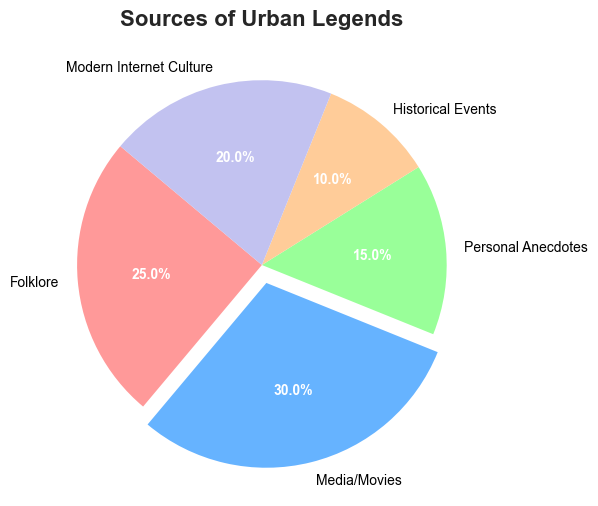What is the largest source of urban legends? The figure shows a pie chart with different sources of urban legends. The segment labeled 'Media/Movies' has the highest percentage at 30%.
Answer: Media/Movies What is the smallest source of urban legends? By examining the pie chart, the segment labeled 'Historical Events' has the smallest percentage at 10%.
Answer: Historical Events Which source is represented by the red slice? The pie chart uses different colors for the segments, and the legend/helper labels guide us. The 'Folklore' category is represented by the red slice.
Answer: Folklore What is the combined percentage of urban legends from Personal Anecdotes and Modern Internet Culture? The percentages for Personal Anecdotes and Modern Internet Culture are 15% and 20%, respectively. Adding them gives 15 + 20 = 35%.
Answer: 35% How much larger is the Media/Movies segment compared to the Historical Events segment? The percentage for Media/Movies is 30%, and for Historical Events, it is 10%. The difference is 30 - 10 = 20%.
Answer: 20% What percentage of urban legends come from sources other than Media/Movies? The total percentage is 100%. The Media/Movies segment is 30%. So, the percentage from other sources is 100 - 30 = 70%.
Answer: 70% Which two sources have the closest percentages? By examining the pie chart, Folklore and Modern Internet Culture have percentages of 25% and 20%, respectively. The difference between them is 5%, making them the closest in percentage.
Answer: Folklore and Modern Internet Culture How much more prevalent are urban legends from Media/Movies than those from Modern Internet Culture? Media/Movies has a percentage of 30%, and Modern Internet Culture has 20%. The difference is 30 - 20 = 10%.
Answer: 10% What is the total percentage of urban legends attributed to Folklore and Media/Movies combined? Adding the percentages for Folklore (25%) and Media/Movies (30%) gives 25 + 30 = 55%.
Answer: 55% What is the average percentage of urban legends across all categories? The sum of all percentages is 25 + 30 + 15 + 10 + 20 = 100. Since there are 5 categories, the average is 100 / 5 = 20%.
Answer: 20% 